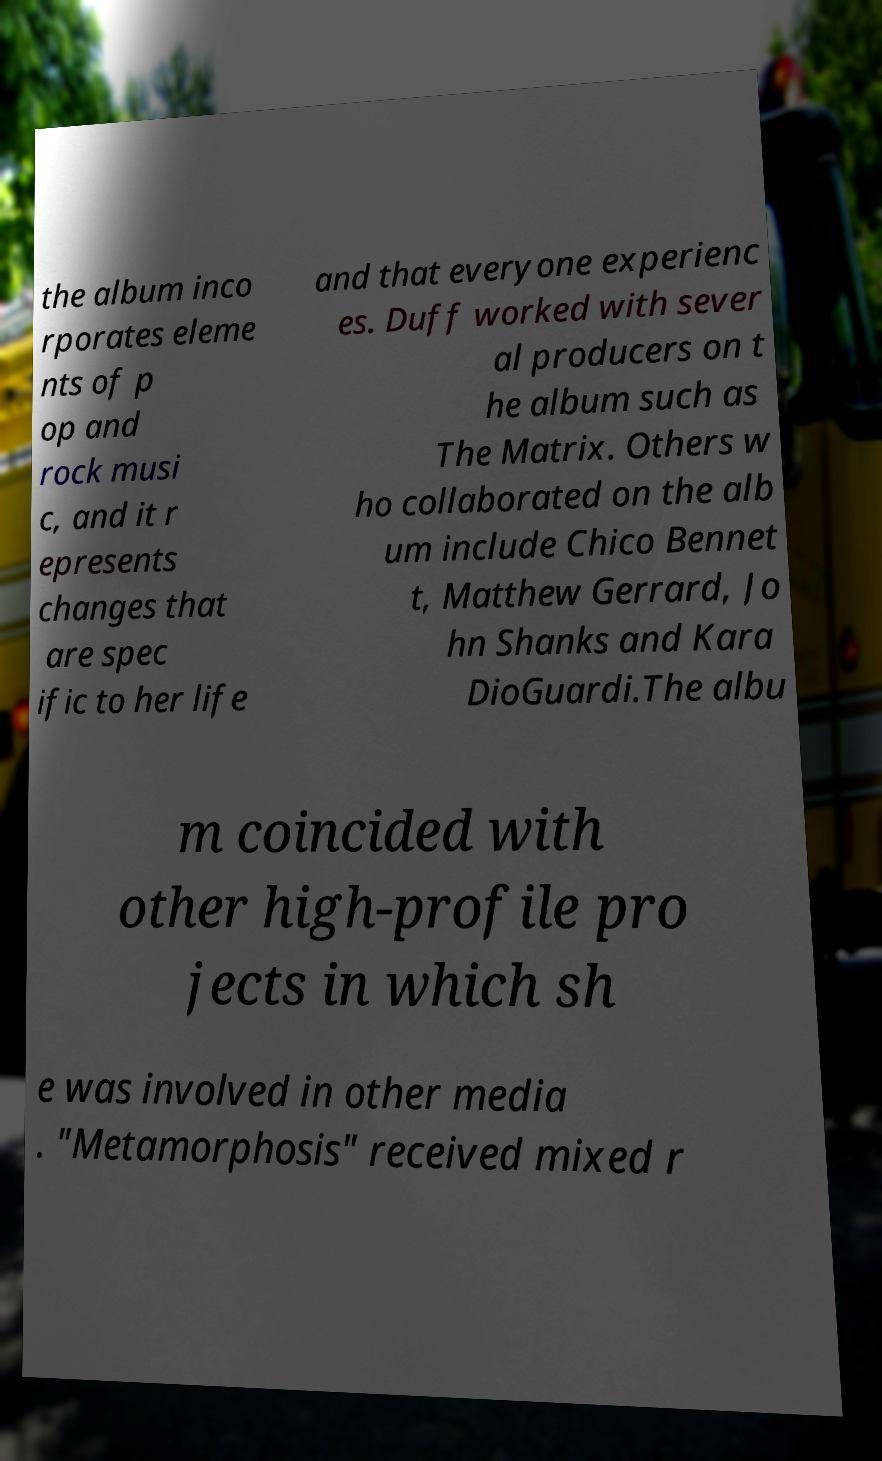Can you accurately transcribe the text from the provided image for me? the album inco rporates eleme nts of p op and rock musi c, and it r epresents changes that are spec ific to her life and that everyone experienc es. Duff worked with sever al producers on t he album such as The Matrix. Others w ho collaborated on the alb um include Chico Bennet t, Matthew Gerrard, Jo hn Shanks and Kara DioGuardi.The albu m coincided with other high-profile pro jects in which sh e was involved in other media . "Metamorphosis" received mixed r 